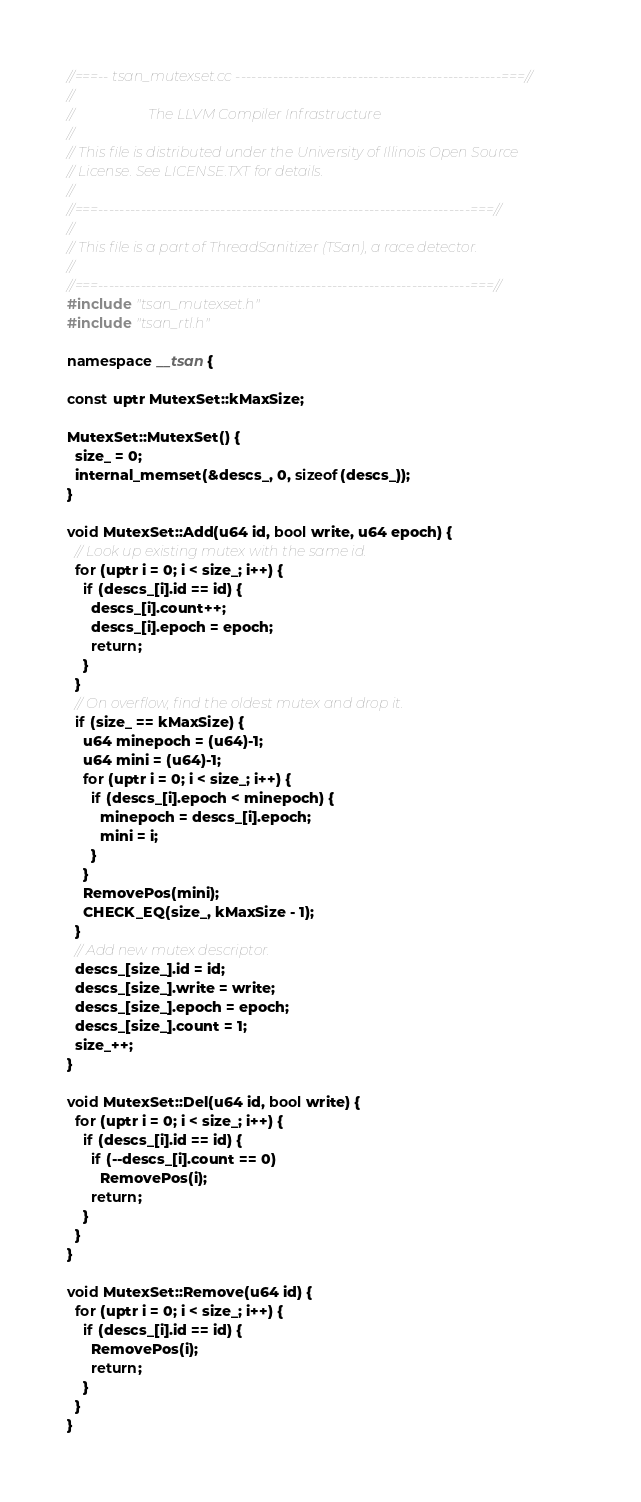Convert code to text. <code><loc_0><loc_0><loc_500><loc_500><_C++_>//===-- tsan_mutexset.cc --------------------------------------------------===//
//
//                     The LLVM Compiler Infrastructure
//
// This file is distributed under the University of Illinois Open Source
// License. See LICENSE.TXT for details.
//
//===----------------------------------------------------------------------===//
//
// This file is a part of ThreadSanitizer (TSan), a race detector.
//
//===----------------------------------------------------------------------===//
#include "tsan_mutexset.h"
#include "tsan_rtl.h"

namespace __tsan {

const uptr MutexSet::kMaxSize;

MutexSet::MutexSet() {
  size_ = 0;
  internal_memset(&descs_, 0, sizeof(descs_));
}

void MutexSet::Add(u64 id, bool write, u64 epoch) {
  // Look up existing mutex with the same id.
  for (uptr i = 0; i < size_; i++) {
    if (descs_[i].id == id) {
      descs_[i].count++;
      descs_[i].epoch = epoch;
      return;
    }
  }
  // On overflow, find the oldest mutex and drop it.
  if (size_ == kMaxSize) {
    u64 minepoch = (u64)-1;
    u64 mini = (u64)-1;
    for (uptr i = 0; i < size_; i++) {
      if (descs_[i].epoch < minepoch) {
        minepoch = descs_[i].epoch;
        mini = i;
      }
    }
    RemovePos(mini);
    CHECK_EQ(size_, kMaxSize - 1);
  }
  // Add new mutex descriptor.
  descs_[size_].id = id;
  descs_[size_].write = write;
  descs_[size_].epoch = epoch;
  descs_[size_].count = 1;
  size_++;
}

void MutexSet::Del(u64 id, bool write) {
  for (uptr i = 0; i < size_; i++) {
    if (descs_[i].id == id) {
      if (--descs_[i].count == 0)
        RemovePos(i);
      return;
    }
  }
}

void MutexSet::Remove(u64 id) {
  for (uptr i = 0; i < size_; i++) {
    if (descs_[i].id == id) {
      RemovePos(i);
      return;
    }
  }
}
</code> 